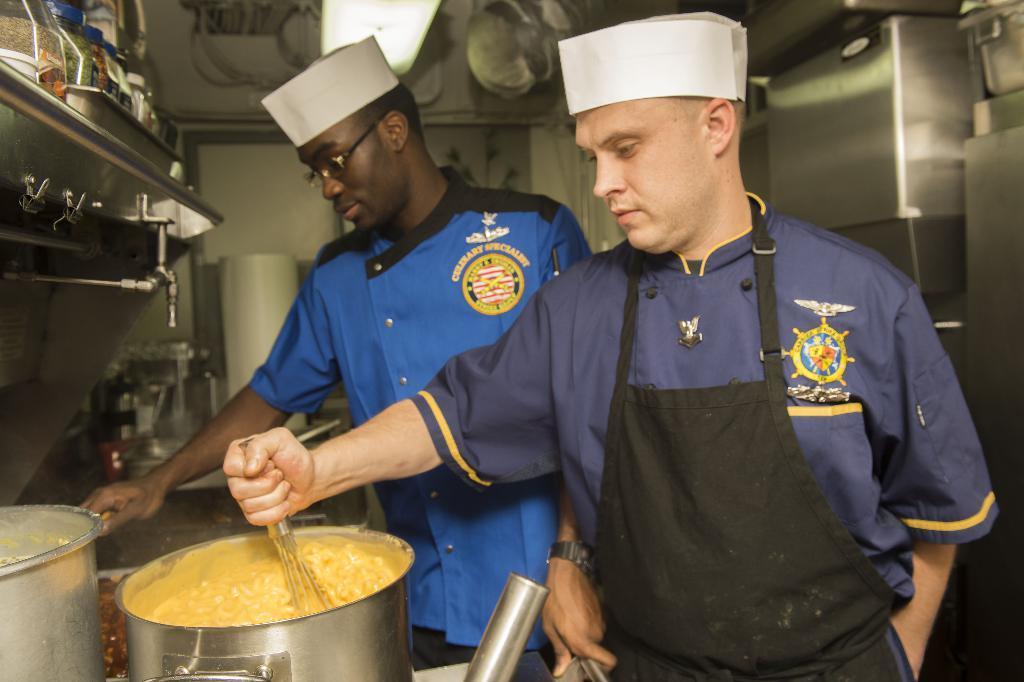In one or two sentences, can you explain what this image depicts? In this image we can see men standing and holding utensils in their hands. In the background we can see walls, pet jars and utensils. 